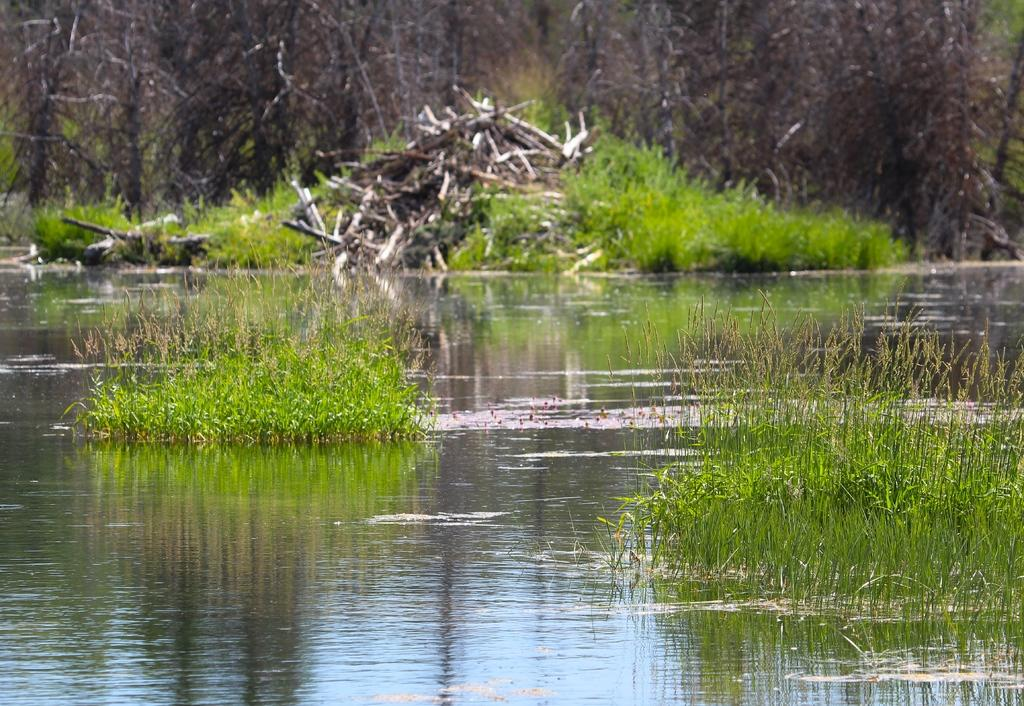What is unusual about the grass in the image? The grass is in the water in the image. What color is the grass? The grass is green. What can be seen in the background of the image? There are dried trees in the background of the image. What type of jeans is the governor wearing in the image? There is no governor or jeans present in the image; it features grass in the water and dried trees in the background. How many cabbages can be seen in the image? There are no cabbages present in the image. 